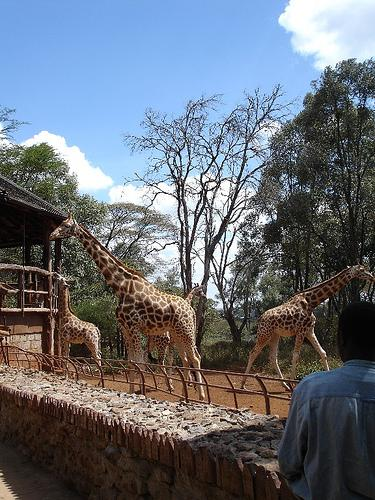What prevents the Giraffes from escaping the fence? thick wall 